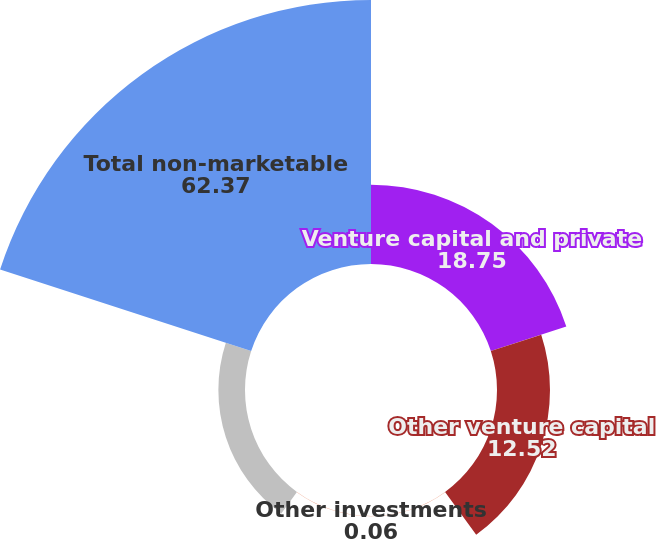<chart> <loc_0><loc_0><loc_500><loc_500><pie_chart><fcel>Venture capital and private<fcel>Other venture capital<fcel>Other investments<fcel>Low income housing tax credit<fcel>Total non-marketable<nl><fcel>18.75%<fcel>12.52%<fcel>0.06%<fcel>6.29%<fcel>62.37%<nl></chart> 